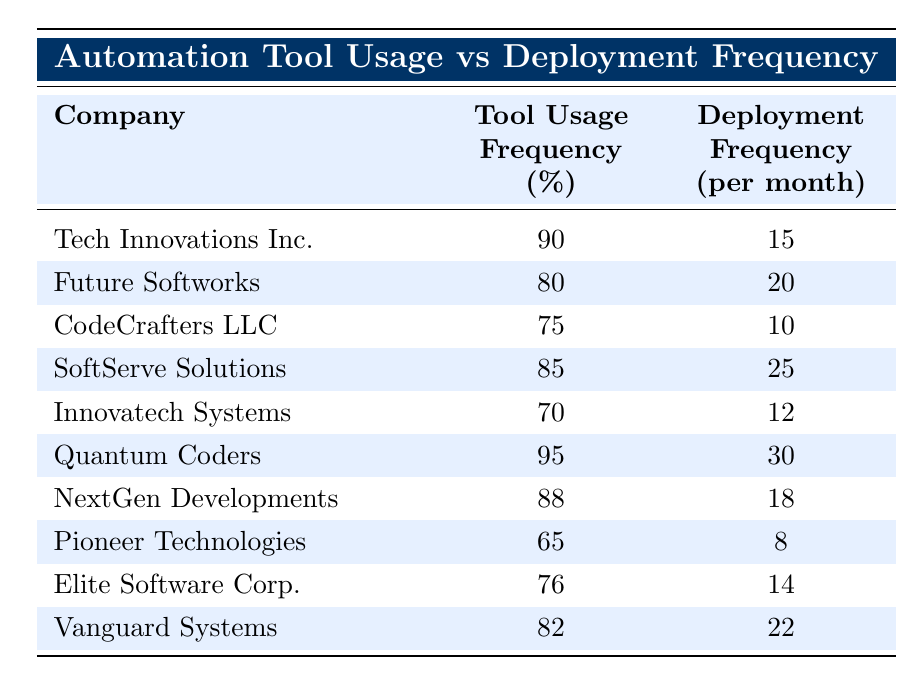What is the tool usage frequency of Quantum Coders? By checking the row corresponding to Quantum Coders in the table, I see that their tool usage frequency is listed as 95%.
Answer: 95% Which company has the highest deployment frequency? Looking at the deployment frequency column, Quantum Coders has the highest value at 30 deployments per month.
Answer: Quantum Coders What is the average tool usage frequency across all companies? There are 10 companies, and their tool usage frequencies are: 90, 80, 75, 85, 70, 95, 88, 65, 76, and 82. Summing these values gives  90 + 80 + 75 + 85 + 70 + 95 + 88 + 65 + 76 + 82 =  915. To find the average, divide by the number of companies: 915/10 = 91.5%.
Answer: 91.5% Is SoftServe Solutions using the highest tool usage frequency among the listed companies? SoftServe Solutions has a tool usage frequency of 85%. By comparing this with all other companies, Quantum Coders has a higher frequency of 95%. Therefore, it's false that SoftServe Solutions has the highest.
Answer: No How many companies have a deployment frequency greater than 20? By reviewing the deployment frequencies: Tech Innovations Inc. (15), Future Softworks (20), CodeCrafters LLC (10), SoftServe Solutions (25), Innovatech Systems (12), Quantum Coders (30), NextGen Developments (18), Pioneer Technologies (8), Elite Software Corp. (14), and Vanguard Systems (22), the companies with a frequency greater than 20 are SoftServe Solutions (25), Quantum Coders (30), and Vanguard Systems (22), totaling 3 companies.
Answer: 3 What is the difference in deployment frequency between the company with the highest and the company with the lowest? The highest deployment frequency is 30 (Quantum Coders) and the lowest is 8 (Pioneer Technologies). The difference is calculated as 30 - 8 = 22.
Answer: 22 Which companies have a tool usage frequency of less than 75%? From the table, the companies with tool usage frequencies below 75% are CodeCrafters LLC (75%), Innovatech Systems (70%), and Pioneer Technologies (65%). Therefore, only Innovatech Systems and Pioneer Technologies fall below 75%.
Answer: Innovatech Systems and Pioneer Technologies Are there more companies with tool usage frequency greater than 80% than those with a deployment frequency less than 15? From the table, companies with tool usage frequency greater than 80% are Tech Innovations Inc., Future Softworks, SoftServe Solutions, Quantum Coders, and NextGen Developments, which totals 5. Companies with deployment frequency less than 15 are CodeCrafters LLC (10), Innovatech Systems (12), and Pioneer Technologies (8), totaling 3. Since 5 is greater than 3, the answer is yes.
Answer: Yes 